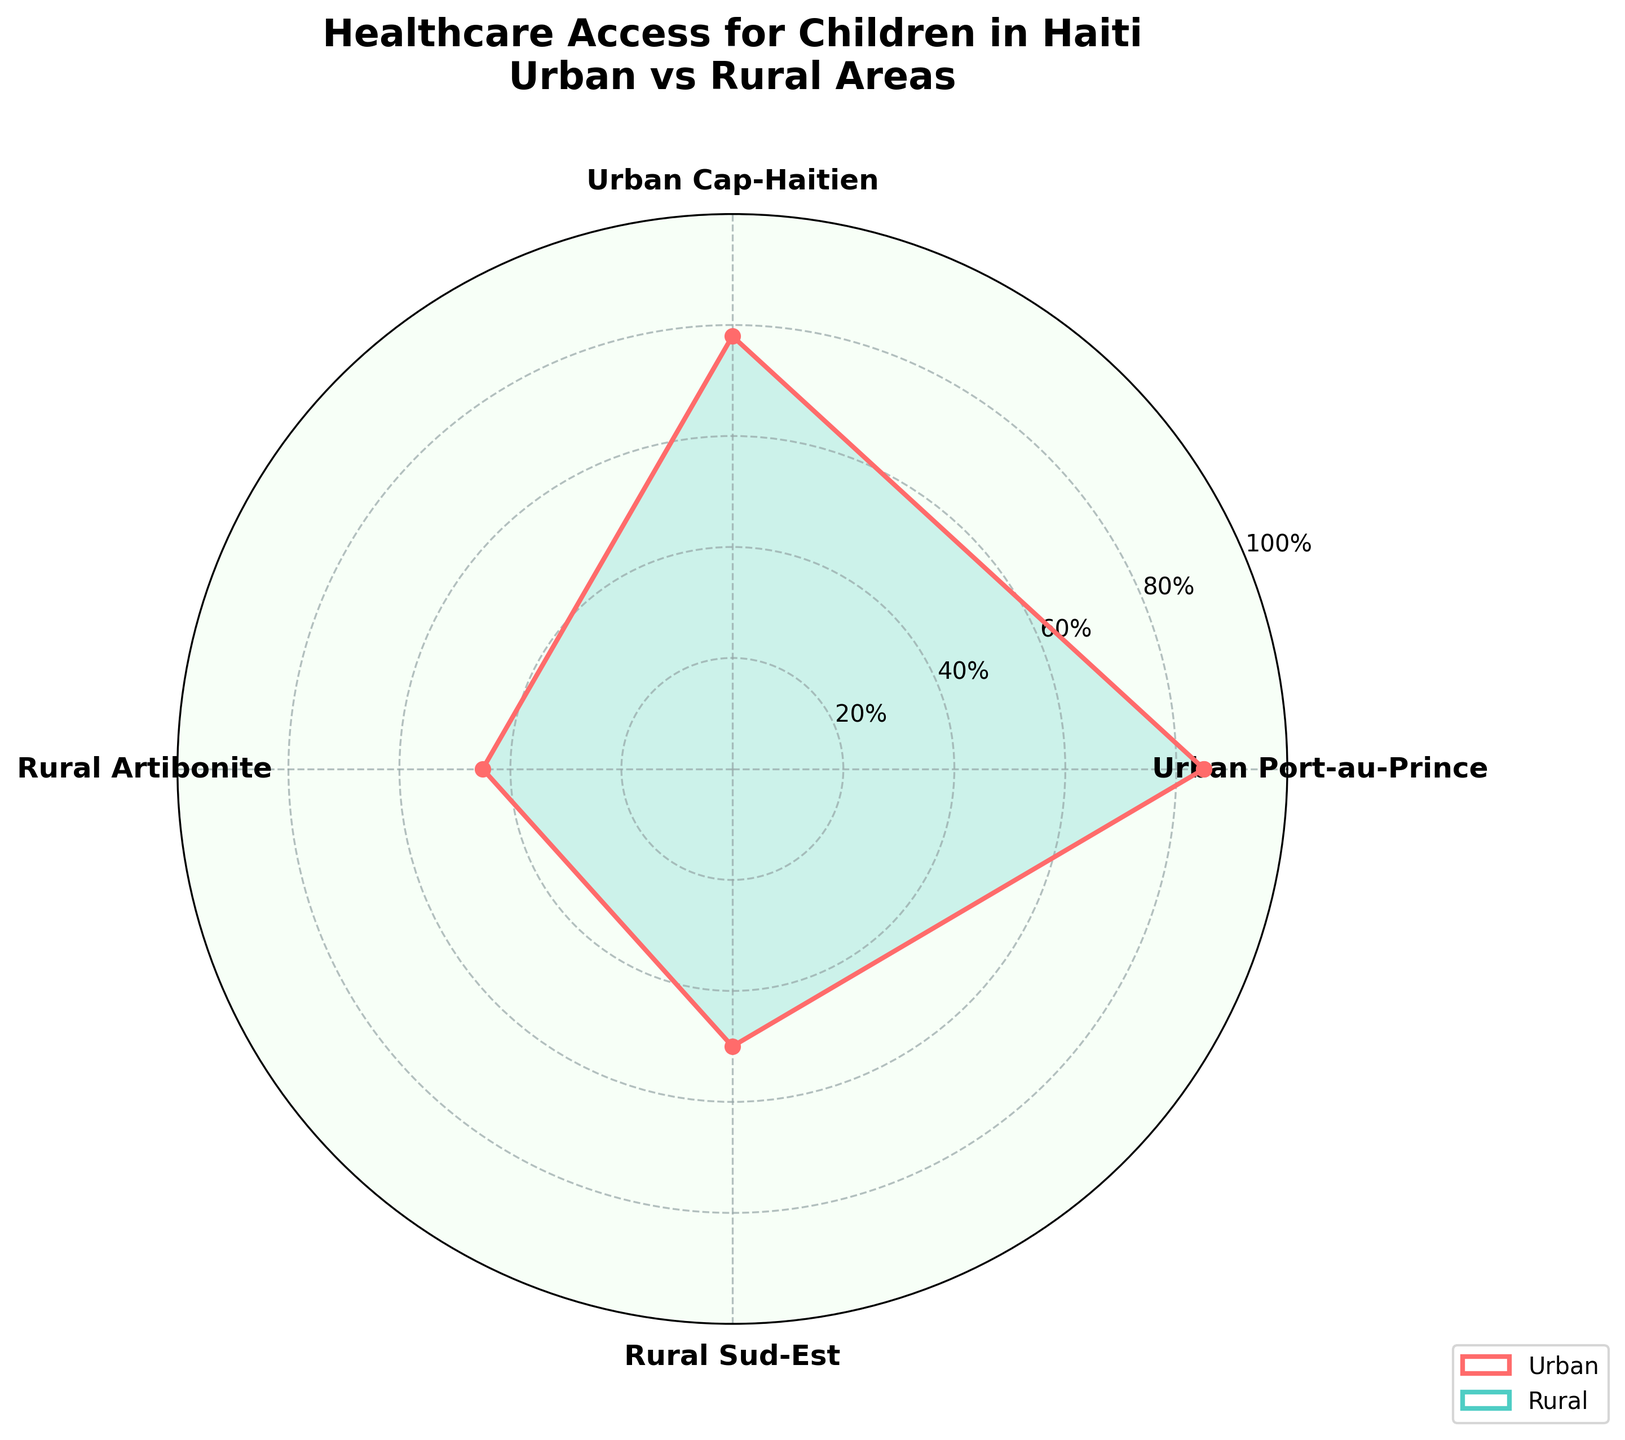How many regions are represented in the rose chart? By looking at the number of labels (regions) around the radial plot's circumference, we can count them. There are four distinct labels mentioned: Urban Port-au-Prince, Urban Cap-Haitien, Rural Artibonite, and Rural Sud-Est.
Answer: 4 What is the title of the rose chart? The title of the chart is typically located at the top of the figure. In this case, it reads "Healthcare Access for Children in Haiti\nUrban vs Rural Areas."
Answer: Healthcare Access for Children in Haiti Urban vs Rural Areas Which region has the highest proportion of healthcare access for children? By looking at the radial length (proportion) for each region, Urban Port-au-Prince has the longest length, indicating the highest proportion of healthcare access at 85%.
Answer: Urban Port-au-Prince What is the proportion of healthcare access for children in Rural Artibonite? From the figure, find the radial length corresponding to Rural Artibonite. The label shows a proportion of 45%.
Answer: 45% What is the average proportion of healthcare access for children in urban areas? To find the average, first add the proportions of Urban Port-au-Prince and Urban Cap-Haitien (85 + 78). Then divide by the number of urban regions (2). The calculation is (85 + 78) / 2 = 81.5.
Answer: 81.5 Which region has a higher proportion of healthcare access for children: Rural Sud-Est or Rural Artibonite? Compare the radial lengths for Rural Sud-Est and Rural Artibonite. Rural Sud-Est has a proportion of 50%, while Rural Artibonite has 45%, making Rural Sud-Est higher.
Answer: Rural Sud-Est What is the difference in healthcare access between the highest and lowest regions? Identify the highest and lowest proportions: Urban Port-au-Prince (85%) and Rural Artibonite (45%). Subtract the lowest from the highest: 85 - 45 = 40.
Answer: 40 How does healthcare access in Urban Cap-Haitien compare to Rural Sud-Est? Compare the proportions visually: Urban Cap-Haitien has 78%, while Rural Sud-Est has 50%. Urban Cap-Haitien has a higher proportion.
Answer: Urban Cap-Haitien What color represents urban regions in the rose chart? Notice the color coding used for urban regions; Urban Port-au-Prince and Urban Cap-Haitien are highlighted in the maroon color.
Answer: Maroon (or a reddish color) Can we say that urban areas generally have better healthcare access than rural areas based on this chart? Compare the average proportions of healthcare access for urban regions (81.5) and rural regions (average of 45% and 50% is 47.5). Urban areas have a significantly higher average proportion, indicating better access.
Answer: Yes 